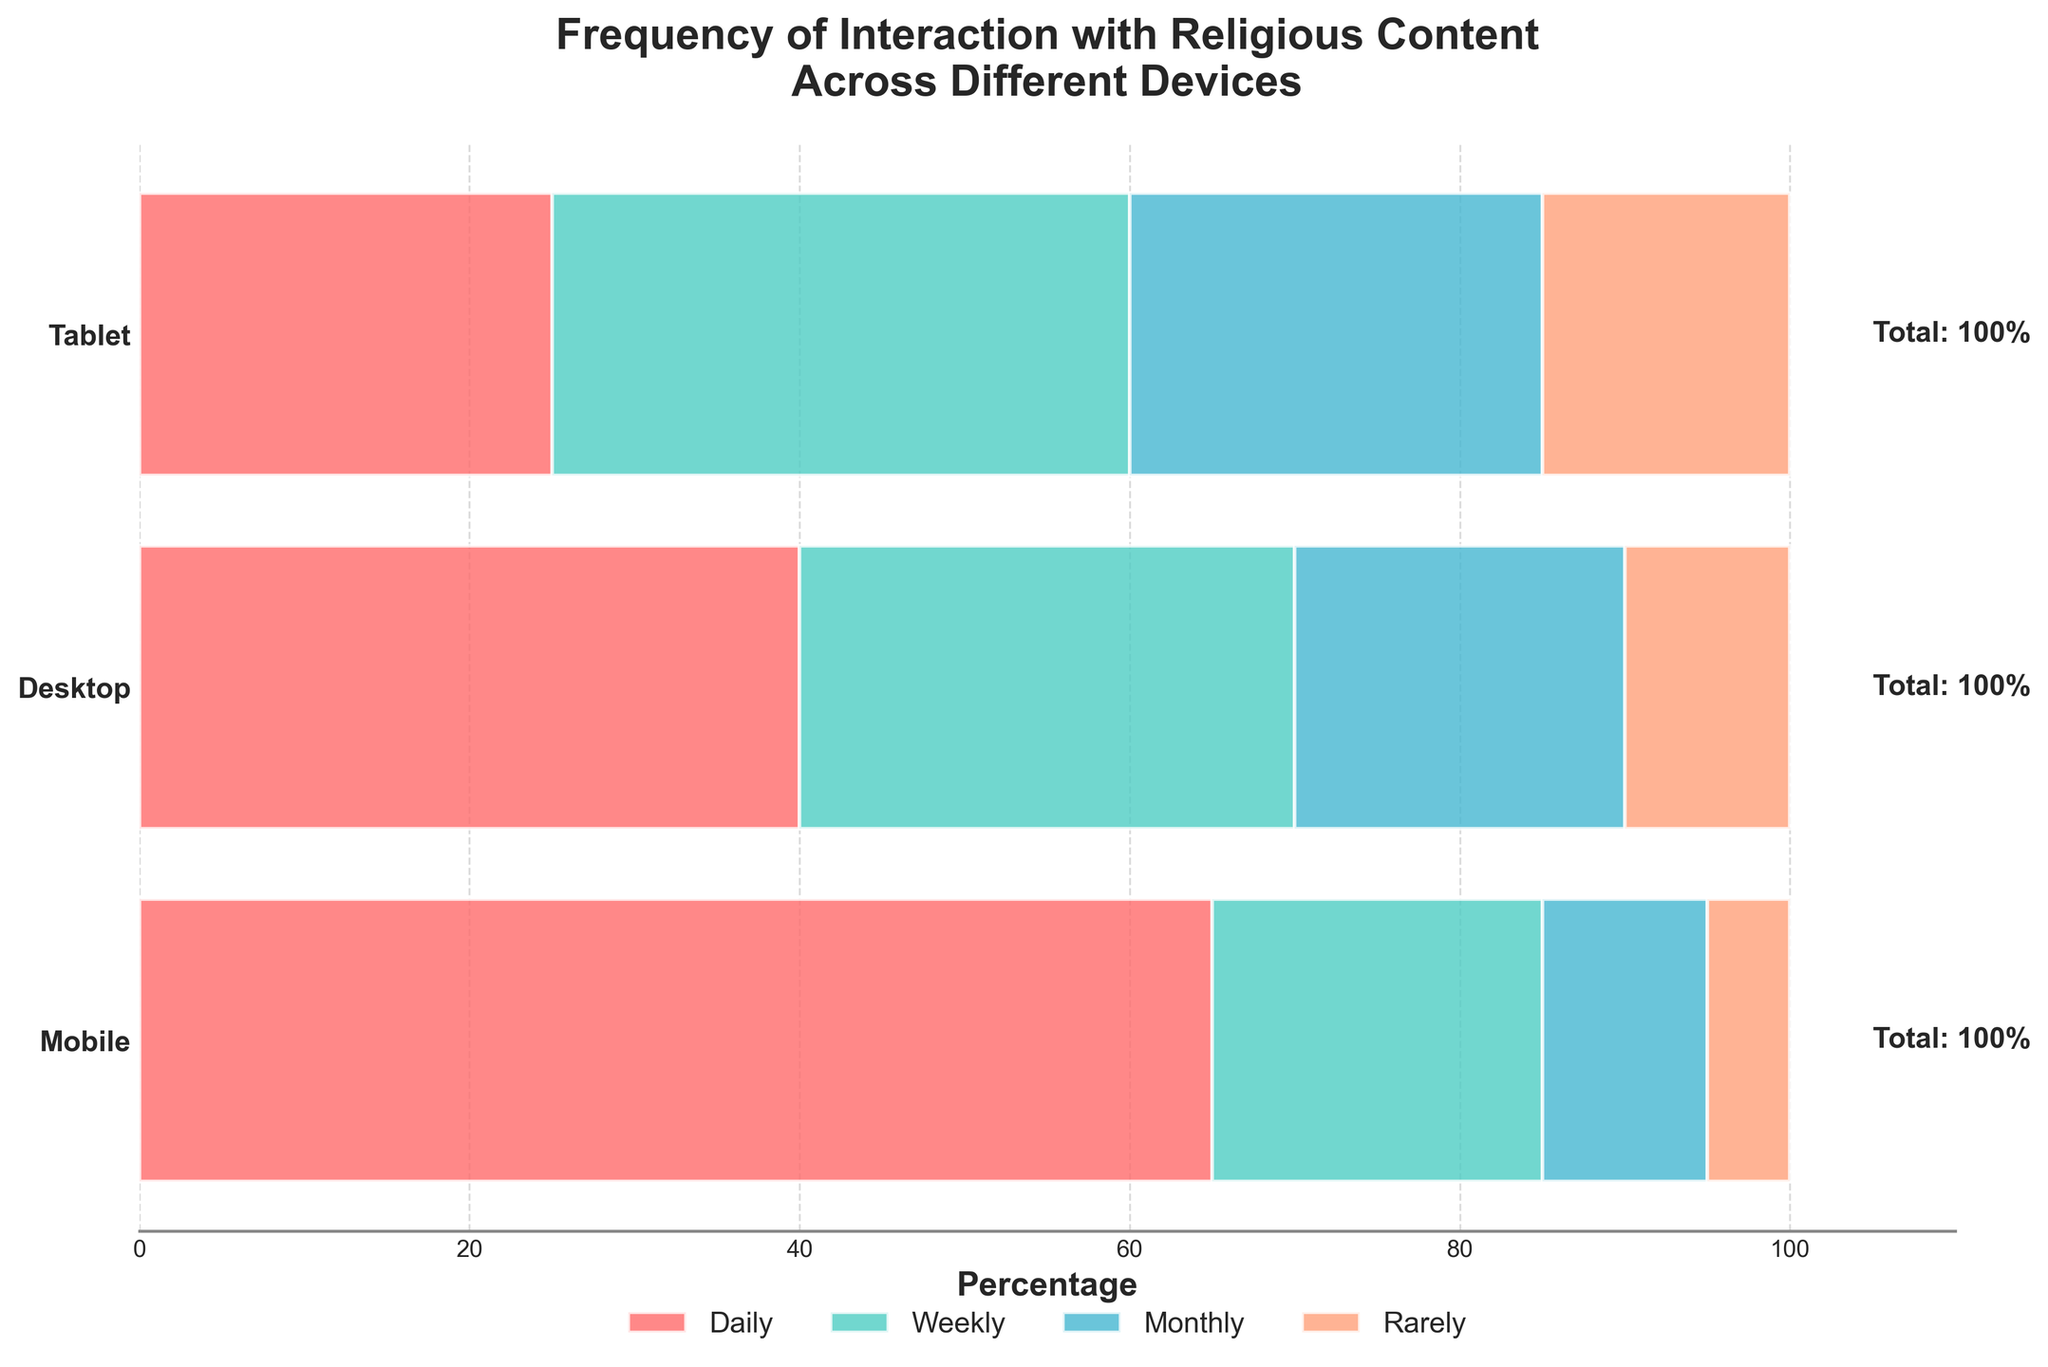What's the title of the figure? The title of the figure is typically found at the top of the chart, giving a summary of what the figure is about. In this case, it should state the purpose clearly.
Answer: Frequency of Interaction with Religious Content Across Different Devices How many device categories are compared in the figure? To determine this, look at the y-axis labels, which usually denote the categories being compared.
Answer: 3 Which device has the highest percentage of daily interactions? Find the "Daily" section (usually represented by a specific color) on the horizontal bars and compare the lengths of the bars for each device.
Answer: Mobile What is the total percentage of interactions for Desktop users? The total percentage for Desktop can be calculated by summing up the percentages of daily, weekly, monthly, and rarely interactions.
Answer: 100% Which frequency category has the smallest percentage for Tablet users? Look at the different sections of the bar for Tablet users and identify which section has the shortest length.
Answer: Daily What's the difference in the percentage of rare interactions between Mobile and Tablet users? Subtract the percentage of rare interactions for Mobile users from that of Tablet users.
Answer: 10% Is the weekly interaction percentage higher for Desktop or Tablet users? Compare the heights of the sections labeled "Weekly" for Desktop and Tablet users.
Answer: Tablet Which device has the most balanced distribution across different interaction frequencies? Look at the percentages of daily, weekly, monthly, and rarely for each device and assess which one has percentages that are closest to each other.
Answer: Tablet What percentage is represented by Mobile users for monthly interactions? Identify the section labeled "Monthly" for Mobile users and note the percentage value.
Answer: 10% On which device do users interact most rarely with religious content? Compare the "Rarely" sections for all devices and see which one is the longest.
Answer: Tablet 